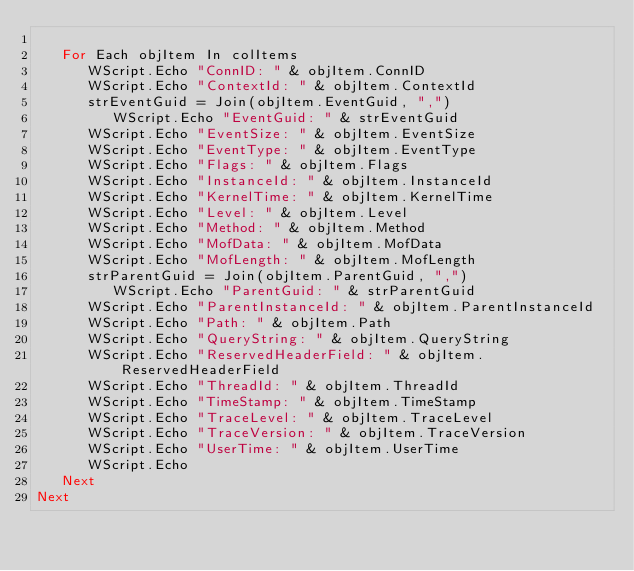<code> <loc_0><loc_0><loc_500><loc_500><_VisualBasic_>
   For Each objItem In colItems
      WScript.Echo "ConnID: " & objItem.ConnID
      WScript.Echo "ContextId: " & objItem.ContextId
      strEventGuid = Join(objItem.EventGuid, ",")
         WScript.Echo "EventGuid: " & strEventGuid
      WScript.Echo "EventSize: " & objItem.EventSize
      WScript.Echo "EventType: " & objItem.EventType
      WScript.Echo "Flags: " & objItem.Flags
      WScript.Echo "InstanceId: " & objItem.InstanceId
      WScript.Echo "KernelTime: " & objItem.KernelTime
      WScript.Echo "Level: " & objItem.Level
      WScript.Echo "Method: " & objItem.Method
      WScript.Echo "MofData: " & objItem.MofData
      WScript.Echo "MofLength: " & objItem.MofLength
      strParentGuid = Join(objItem.ParentGuid, ",")
         WScript.Echo "ParentGuid: " & strParentGuid
      WScript.Echo "ParentInstanceId: " & objItem.ParentInstanceId
      WScript.Echo "Path: " & objItem.Path
      WScript.Echo "QueryString: " & objItem.QueryString
      WScript.Echo "ReservedHeaderField: " & objItem.ReservedHeaderField
      WScript.Echo "ThreadId: " & objItem.ThreadId
      WScript.Echo "TimeStamp: " & objItem.TimeStamp
      WScript.Echo "TraceLevel: " & objItem.TraceLevel
      WScript.Echo "TraceVersion: " & objItem.TraceVersion
      WScript.Echo "UserTime: " & objItem.UserTime
      WScript.Echo
   Next
Next

</code> 